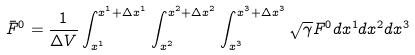<formula> <loc_0><loc_0><loc_500><loc_500>\bar { F } ^ { 0 } = \frac { 1 } { \Delta V } \int _ { x ^ { 1 } } ^ { x ^ { 1 } + \Delta x ^ { 1 } } \int _ { x ^ { 2 } } ^ { x ^ { 2 } + \Delta x ^ { 2 } } \int _ { x ^ { 3 } } ^ { x ^ { 3 } + \Delta x ^ { 3 } } \sqrt { \gamma } { F } ^ { 0 } d x ^ { 1 } d x ^ { 2 } d x ^ { 3 }</formula> 